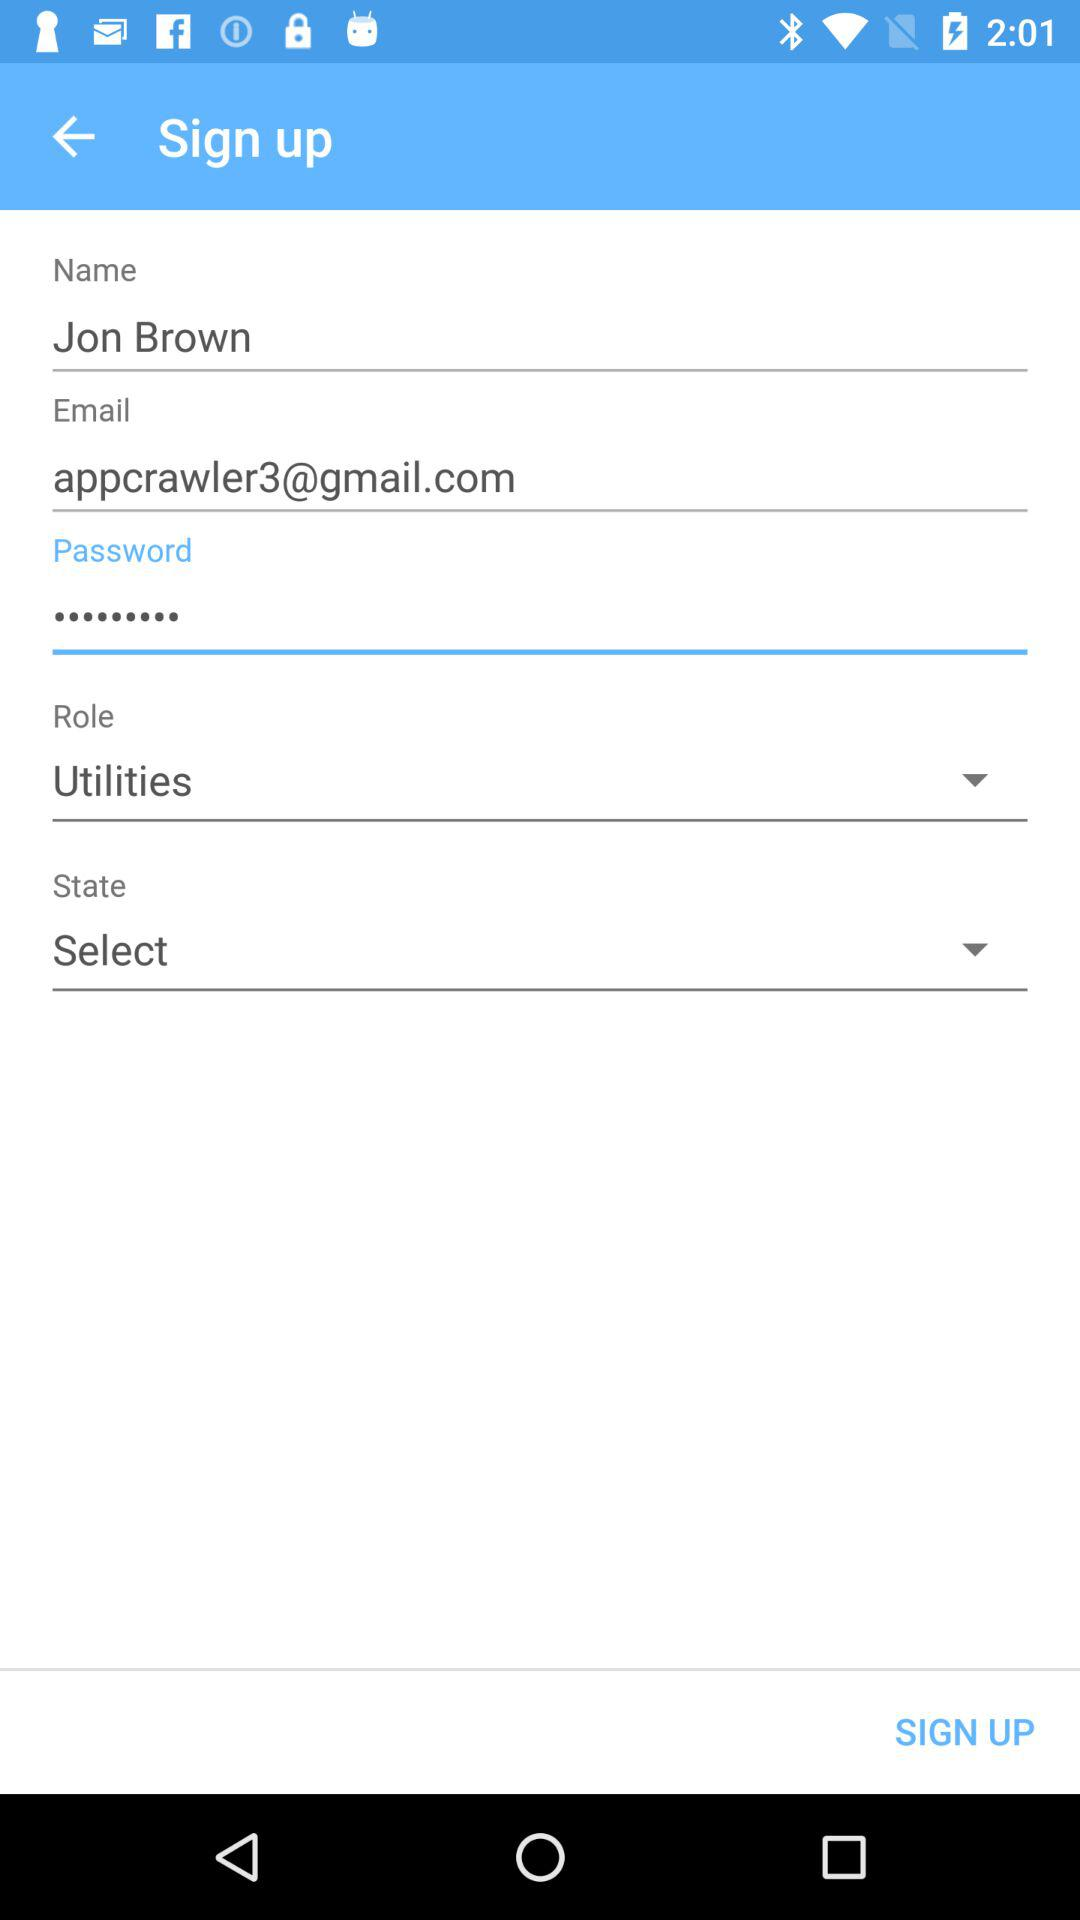What is the user name? The user name is Jon Brown. 